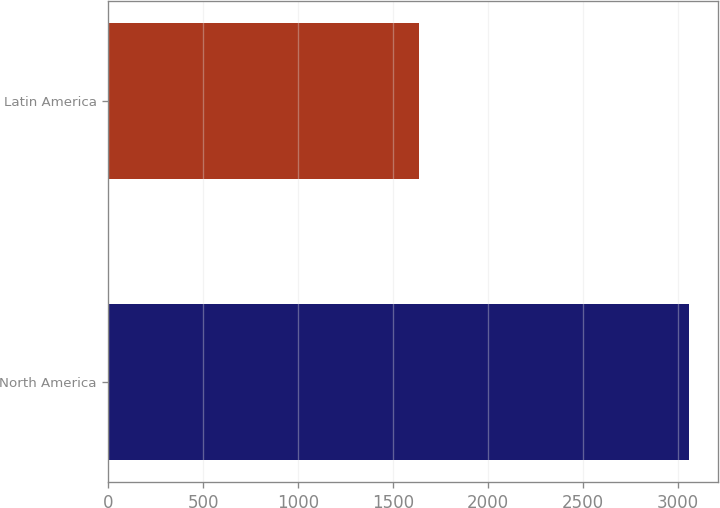<chart> <loc_0><loc_0><loc_500><loc_500><bar_chart><fcel>North America<fcel>Latin America<nl><fcel>3057<fcel>1639<nl></chart> 